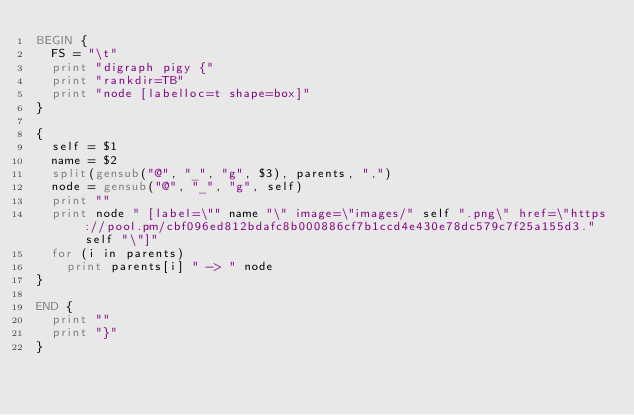Convert code to text. <code><loc_0><loc_0><loc_500><loc_500><_Awk_>BEGIN {
  FS = "\t"
  print "digraph pigy {"
  print "rankdir=TB"
  print "node [labelloc=t shape=box]"
}

{
  self = $1
  name = $2
  split(gensub("@", "_", "g", $3), parents, ",")
  node = gensub("@", "_", "g", self)
  print ""
  print node " [label=\"" name "\" image=\"images/" self ".png\" href=\"https://pool.pm/cbf096ed812bdafc8b000886cf7b1ccd4e430e78dc579c7f25a155d3." self "\"]"
  for (i in parents)
    print parents[i] " -> " node
}

END {
  print ""
  print "}"
}
</code> 